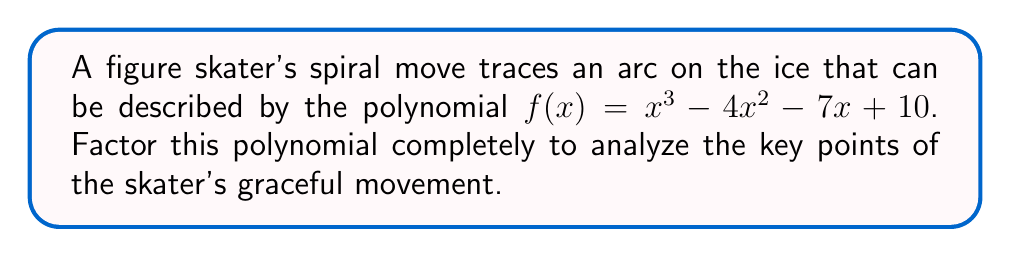What is the answer to this math problem? To factor this polynomial, we'll follow these steps:

1) First, let's check if there are any rational roots using the rational root theorem. The possible rational roots are the factors of the constant term: ±1, ±2, ±5, ±10.

2) Testing these values, we find that $f(1) = 0$. So $(x-1)$ is a factor.

3) We can use polynomial long division to divide $f(x)$ by $(x-1)$:

   $$x^3 - 4x^2 - 7x + 10 = (x-1)(x^2 - 3x - 10)$$

4) Now we need to factor the quadratic $x^2 - 3x - 10$. We can do this by finding two numbers that multiply to give -10 and add to give -3. These numbers are -5 and 2.

5) Therefore, $x^2 - 3x - 10 = (x-5)(x+2)$

6) Putting it all together:

   $$f(x) = x^3 - 4x^2 - 7x + 10 = (x-1)(x-5)(x+2)$$

This factorization reveals the x-intercepts of the curve, which correspond to key points in the skater's spiral: when $x = 1$, $x = 5$, and $x = -2$. These could represent the starting point, peak, and end of the spiral move.
Answer: $f(x) = (x-1)(x-5)(x+2)$ 